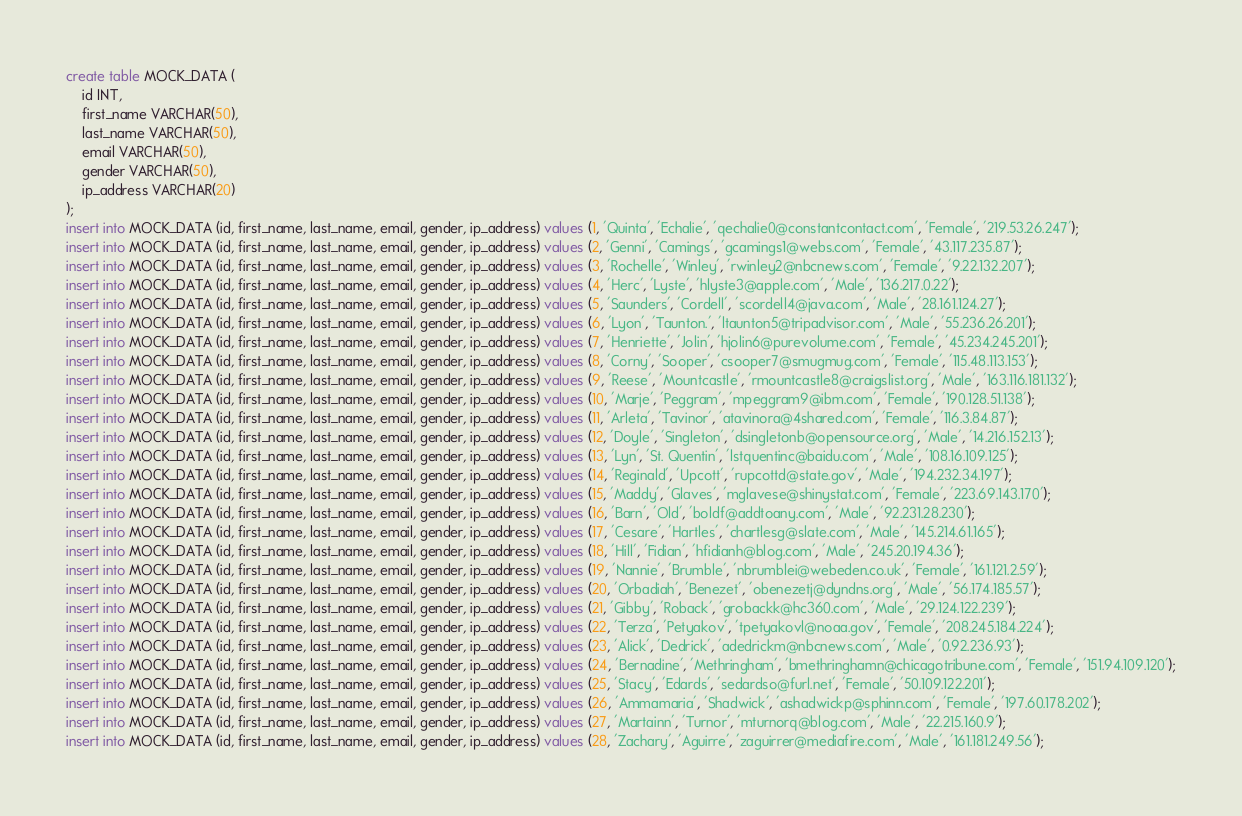Convert code to text. <code><loc_0><loc_0><loc_500><loc_500><_SQL_>create table MOCK_DATA (
	id INT,
	first_name VARCHAR(50),
	last_name VARCHAR(50),
	email VARCHAR(50),
	gender VARCHAR(50),
	ip_address VARCHAR(20)
);
insert into MOCK_DATA (id, first_name, last_name, email, gender, ip_address) values (1, 'Quinta', 'Echalie', 'qechalie0@constantcontact.com', 'Female', '219.53.26.247');
insert into MOCK_DATA (id, first_name, last_name, email, gender, ip_address) values (2, 'Genni', 'Camings', 'gcamings1@webs.com', 'Female', '43.117.235.87');
insert into MOCK_DATA (id, first_name, last_name, email, gender, ip_address) values (3, 'Rochelle', 'Winley', 'rwinley2@nbcnews.com', 'Female', '9.22.132.207');
insert into MOCK_DATA (id, first_name, last_name, email, gender, ip_address) values (4, 'Herc', 'Lyste', 'hlyste3@apple.com', 'Male', '136.217.0.22');
insert into MOCK_DATA (id, first_name, last_name, email, gender, ip_address) values (5, 'Saunders', 'Cordell', 'scordell4@java.com', 'Male', '28.161.124.27');
insert into MOCK_DATA (id, first_name, last_name, email, gender, ip_address) values (6, 'Lyon', 'Taunton.', 'ltaunton5@tripadvisor.com', 'Male', '55.236.26.201');
insert into MOCK_DATA (id, first_name, last_name, email, gender, ip_address) values (7, 'Henriette', 'Jolin', 'hjolin6@purevolume.com', 'Female', '45.234.245.201');
insert into MOCK_DATA (id, first_name, last_name, email, gender, ip_address) values (8, 'Corny', 'Sooper', 'csooper7@smugmug.com', 'Female', '115.48.113.153');
insert into MOCK_DATA (id, first_name, last_name, email, gender, ip_address) values (9, 'Reese', 'Mountcastle', 'rmountcastle8@craigslist.org', 'Male', '163.116.181.132');
insert into MOCK_DATA (id, first_name, last_name, email, gender, ip_address) values (10, 'Marje', 'Peggram', 'mpeggram9@ibm.com', 'Female', '190.128.51.138');
insert into MOCK_DATA (id, first_name, last_name, email, gender, ip_address) values (11, 'Arleta', 'Tavinor', 'atavinora@4shared.com', 'Female', '116.3.84.87');
insert into MOCK_DATA (id, first_name, last_name, email, gender, ip_address) values (12, 'Doyle', 'Singleton', 'dsingletonb@opensource.org', 'Male', '14.216.152.13');
insert into MOCK_DATA (id, first_name, last_name, email, gender, ip_address) values (13, 'Lyn', 'St. Quentin', 'lstquentinc@baidu.com', 'Male', '108.16.109.125');
insert into MOCK_DATA (id, first_name, last_name, email, gender, ip_address) values (14, 'Reginald', 'Upcott', 'rupcottd@state.gov', 'Male', '194.232.34.197');
insert into MOCK_DATA (id, first_name, last_name, email, gender, ip_address) values (15, 'Maddy', 'Glaves', 'mglavese@shinystat.com', 'Female', '223.69.143.170');
insert into MOCK_DATA (id, first_name, last_name, email, gender, ip_address) values (16, 'Barn', 'Old', 'boldf@addtoany.com', 'Male', '92.231.28.230');
insert into MOCK_DATA (id, first_name, last_name, email, gender, ip_address) values (17, 'Cesare', 'Hartles', 'chartlesg@slate.com', 'Male', '145.214.61.165');
insert into MOCK_DATA (id, first_name, last_name, email, gender, ip_address) values (18, 'Hill', 'Fidian', 'hfidianh@blog.com', 'Male', '245.20.194.36');
insert into MOCK_DATA (id, first_name, last_name, email, gender, ip_address) values (19, 'Nannie', 'Brumble', 'nbrumblei@webeden.co.uk', 'Female', '161.121.2.59');
insert into MOCK_DATA (id, first_name, last_name, email, gender, ip_address) values (20, 'Orbadiah', 'Benezet', 'obenezetj@dyndns.org', 'Male', '56.174.185.57');
insert into MOCK_DATA (id, first_name, last_name, email, gender, ip_address) values (21, 'Gibby', 'Roback', 'grobackk@hc360.com', 'Male', '29.124.122.239');
insert into MOCK_DATA (id, first_name, last_name, email, gender, ip_address) values (22, 'Terza', 'Petyakov', 'tpetyakovl@noaa.gov', 'Female', '208.245.184.224');
insert into MOCK_DATA (id, first_name, last_name, email, gender, ip_address) values (23, 'Alick', 'Dedrick', 'adedrickm@nbcnews.com', 'Male', '0.92.236.93');
insert into MOCK_DATA (id, first_name, last_name, email, gender, ip_address) values (24, 'Bernadine', 'Methringham', 'bmethringhamn@chicagotribune.com', 'Female', '151.94.109.120');
insert into MOCK_DATA (id, first_name, last_name, email, gender, ip_address) values (25, 'Stacy', 'Edards', 'sedardso@furl.net', 'Female', '50.109.122.201');
insert into MOCK_DATA (id, first_name, last_name, email, gender, ip_address) values (26, 'Ammamaria', 'Shadwick', 'ashadwickp@sphinn.com', 'Female', '197.60.178.202');
insert into MOCK_DATA (id, first_name, last_name, email, gender, ip_address) values (27, 'Martainn', 'Turnor', 'mturnorq@blog.com', 'Male', '22.215.160.9');
insert into MOCK_DATA (id, first_name, last_name, email, gender, ip_address) values (28, 'Zachary', 'Aguirre', 'zaguirrer@mediafire.com', 'Male', '161.181.249.56');</code> 